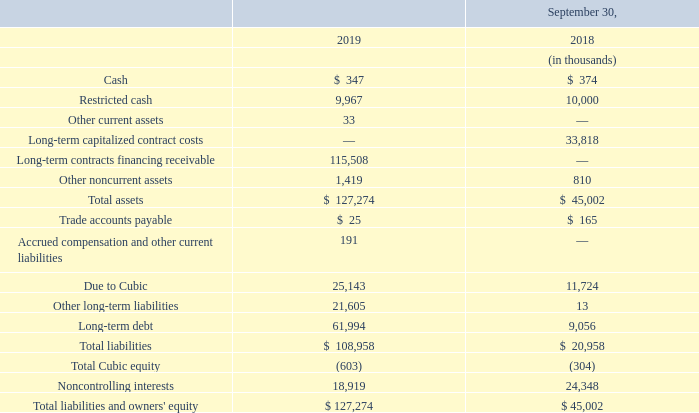The assets and liabilities of OpCo that are included in our Consolidated Balance Sheets at September 30, 2019 and 2018 are as follows:
The assets of OpCo are restricted for OpCo’s use and are not available for the general operations of Cubic. OpCo’s debt is non-recourse to Cubic. Cubic’s maximum exposure to loss as a result of its equity interest in the P3 Venture is limited to the $2.7 million outstanding letter of credit, which will be converted to a cash contribution upon completion of the design and build phase of the MBTA Contract.
What does the table represent? Assets and liabilities of opco that are included in our consolidated balance sheets at september 30, 2019 and 2018. What will Cubic's outstanding letter of credit be converted to? A cash contribution upon completion of the design and build phase of the mbta contract. What are the items under Total assets? Cash, restricted cash, other current assets, long-term capitalized contract costs, long-term contracts financing receivable, other noncurrent assets. In which year is the amount of Cash larger? 374>347
Answer: 2018. What is the change in total assets from 2018 to 2019?
Answer scale should be: thousand. 127,274-45,002
Answer: 82272. What is the percentage change in cash?
Answer scale should be: percent. (347-374)/374
Answer: -7.22. 